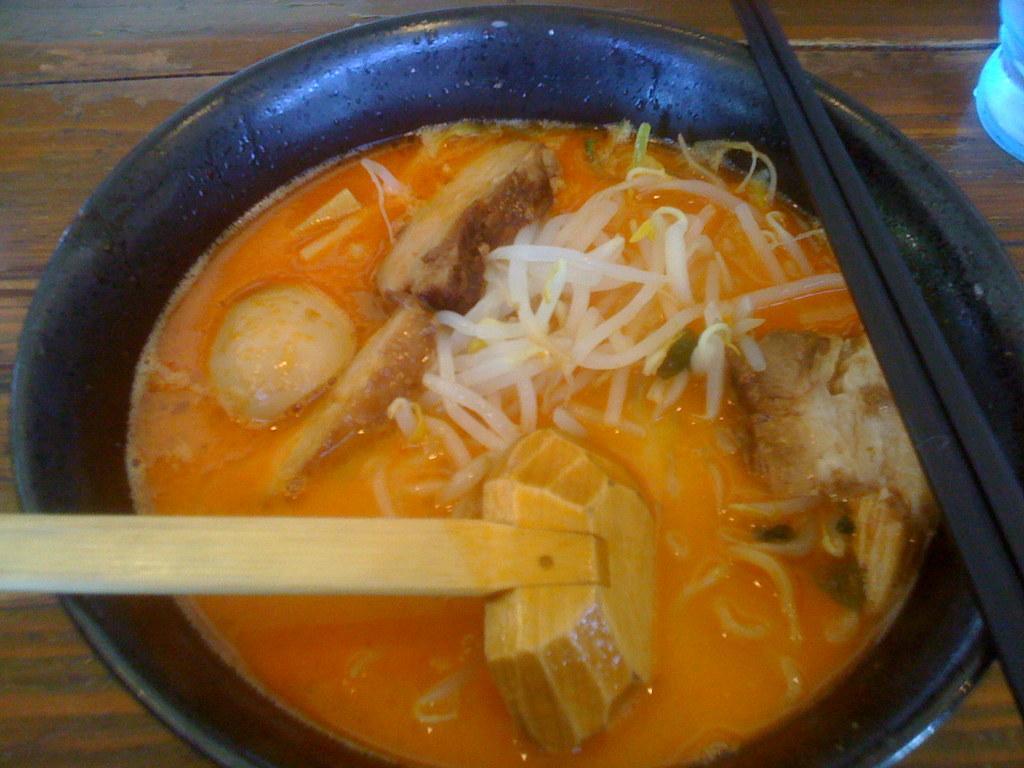Could you give a brief overview of what you see in this image? In this image in the center there is one bowl, and in the bowl there is soup and also there is a spatula and chopsticks. At the bottom there is a wooden table, and on the right side there is some object. 